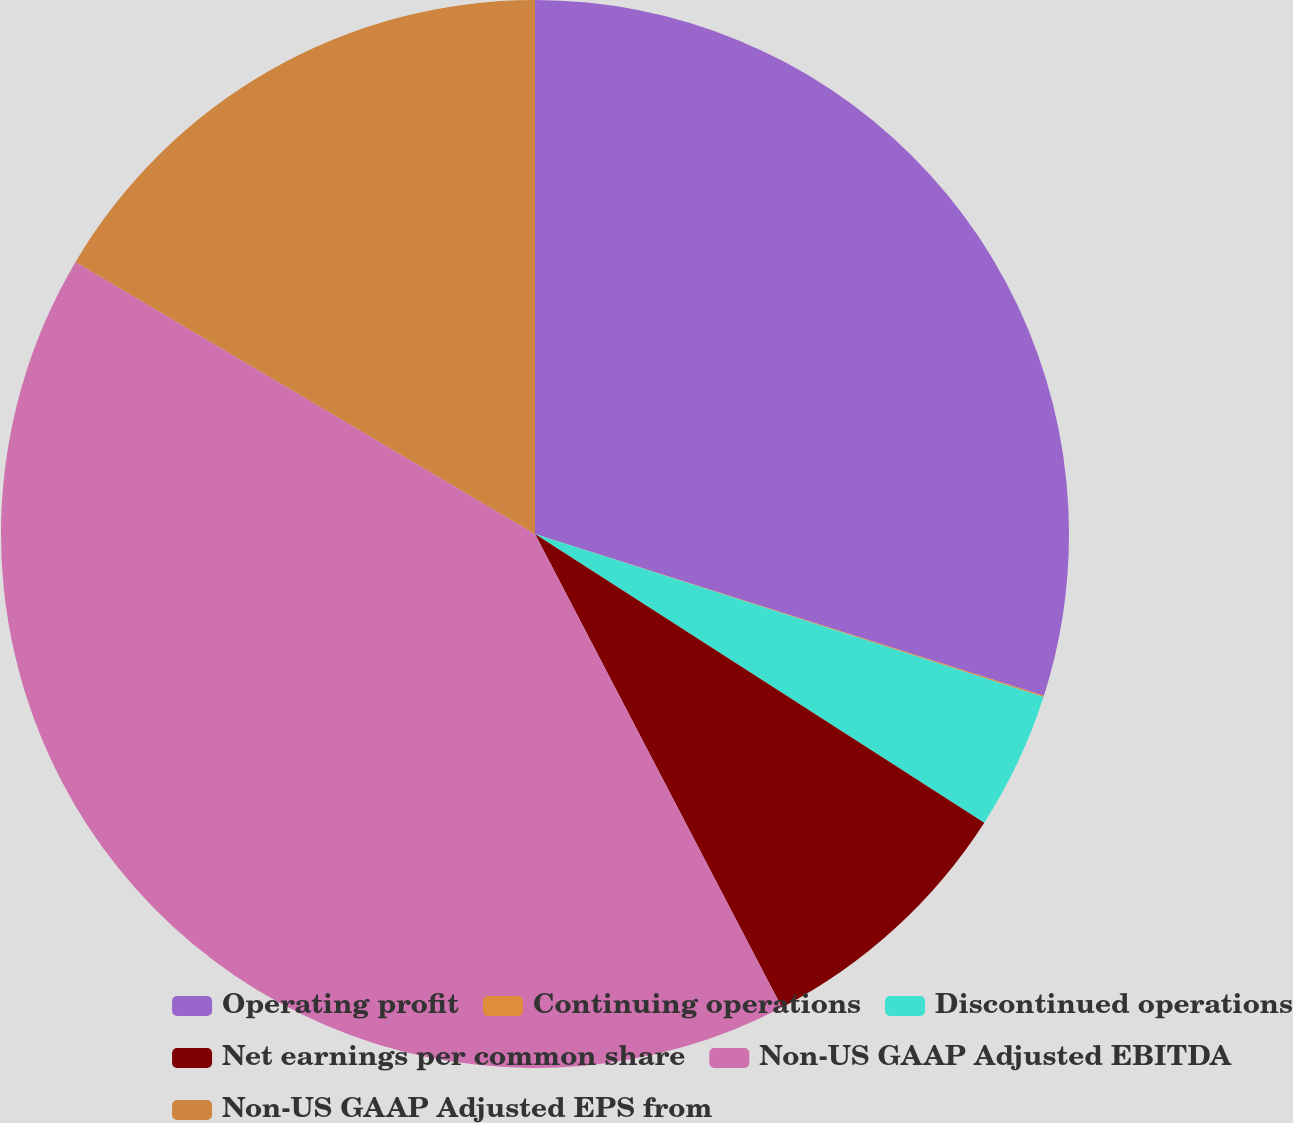<chart> <loc_0><loc_0><loc_500><loc_500><pie_chart><fcel>Operating profit<fcel>Continuing operations<fcel>Discontinued operations<fcel>Net earnings per common share<fcel>Non-US GAAP Adjusted EBITDA<fcel>Non-US GAAP Adjusted EPS from<nl><fcel>29.9%<fcel>0.04%<fcel>4.15%<fcel>8.26%<fcel>41.16%<fcel>16.49%<nl></chart> 